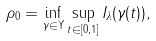<formula> <loc_0><loc_0><loc_500><loc_500>\rho _ { 0 } = \inf _ { \gamma \in \Upsilon } \sup _ { t \in [ 0 , 1 ] } I _ { \lambda } ( \gamma ( t ) ) ,</formula> 